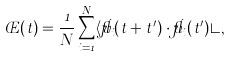Convert formula to latex. <formula><loc_0><loc_0><loc_500><loc_500>\phi ( t ) = \frac { 1 } { N } \sum _ { i = 1 } ^ { N } \langle \vec { v } _ { i } ( t + t ^ { \prime } ) \cdot \vec { v } _ { i } ( t ^ { \prime } ) \rangle ,</formula> 